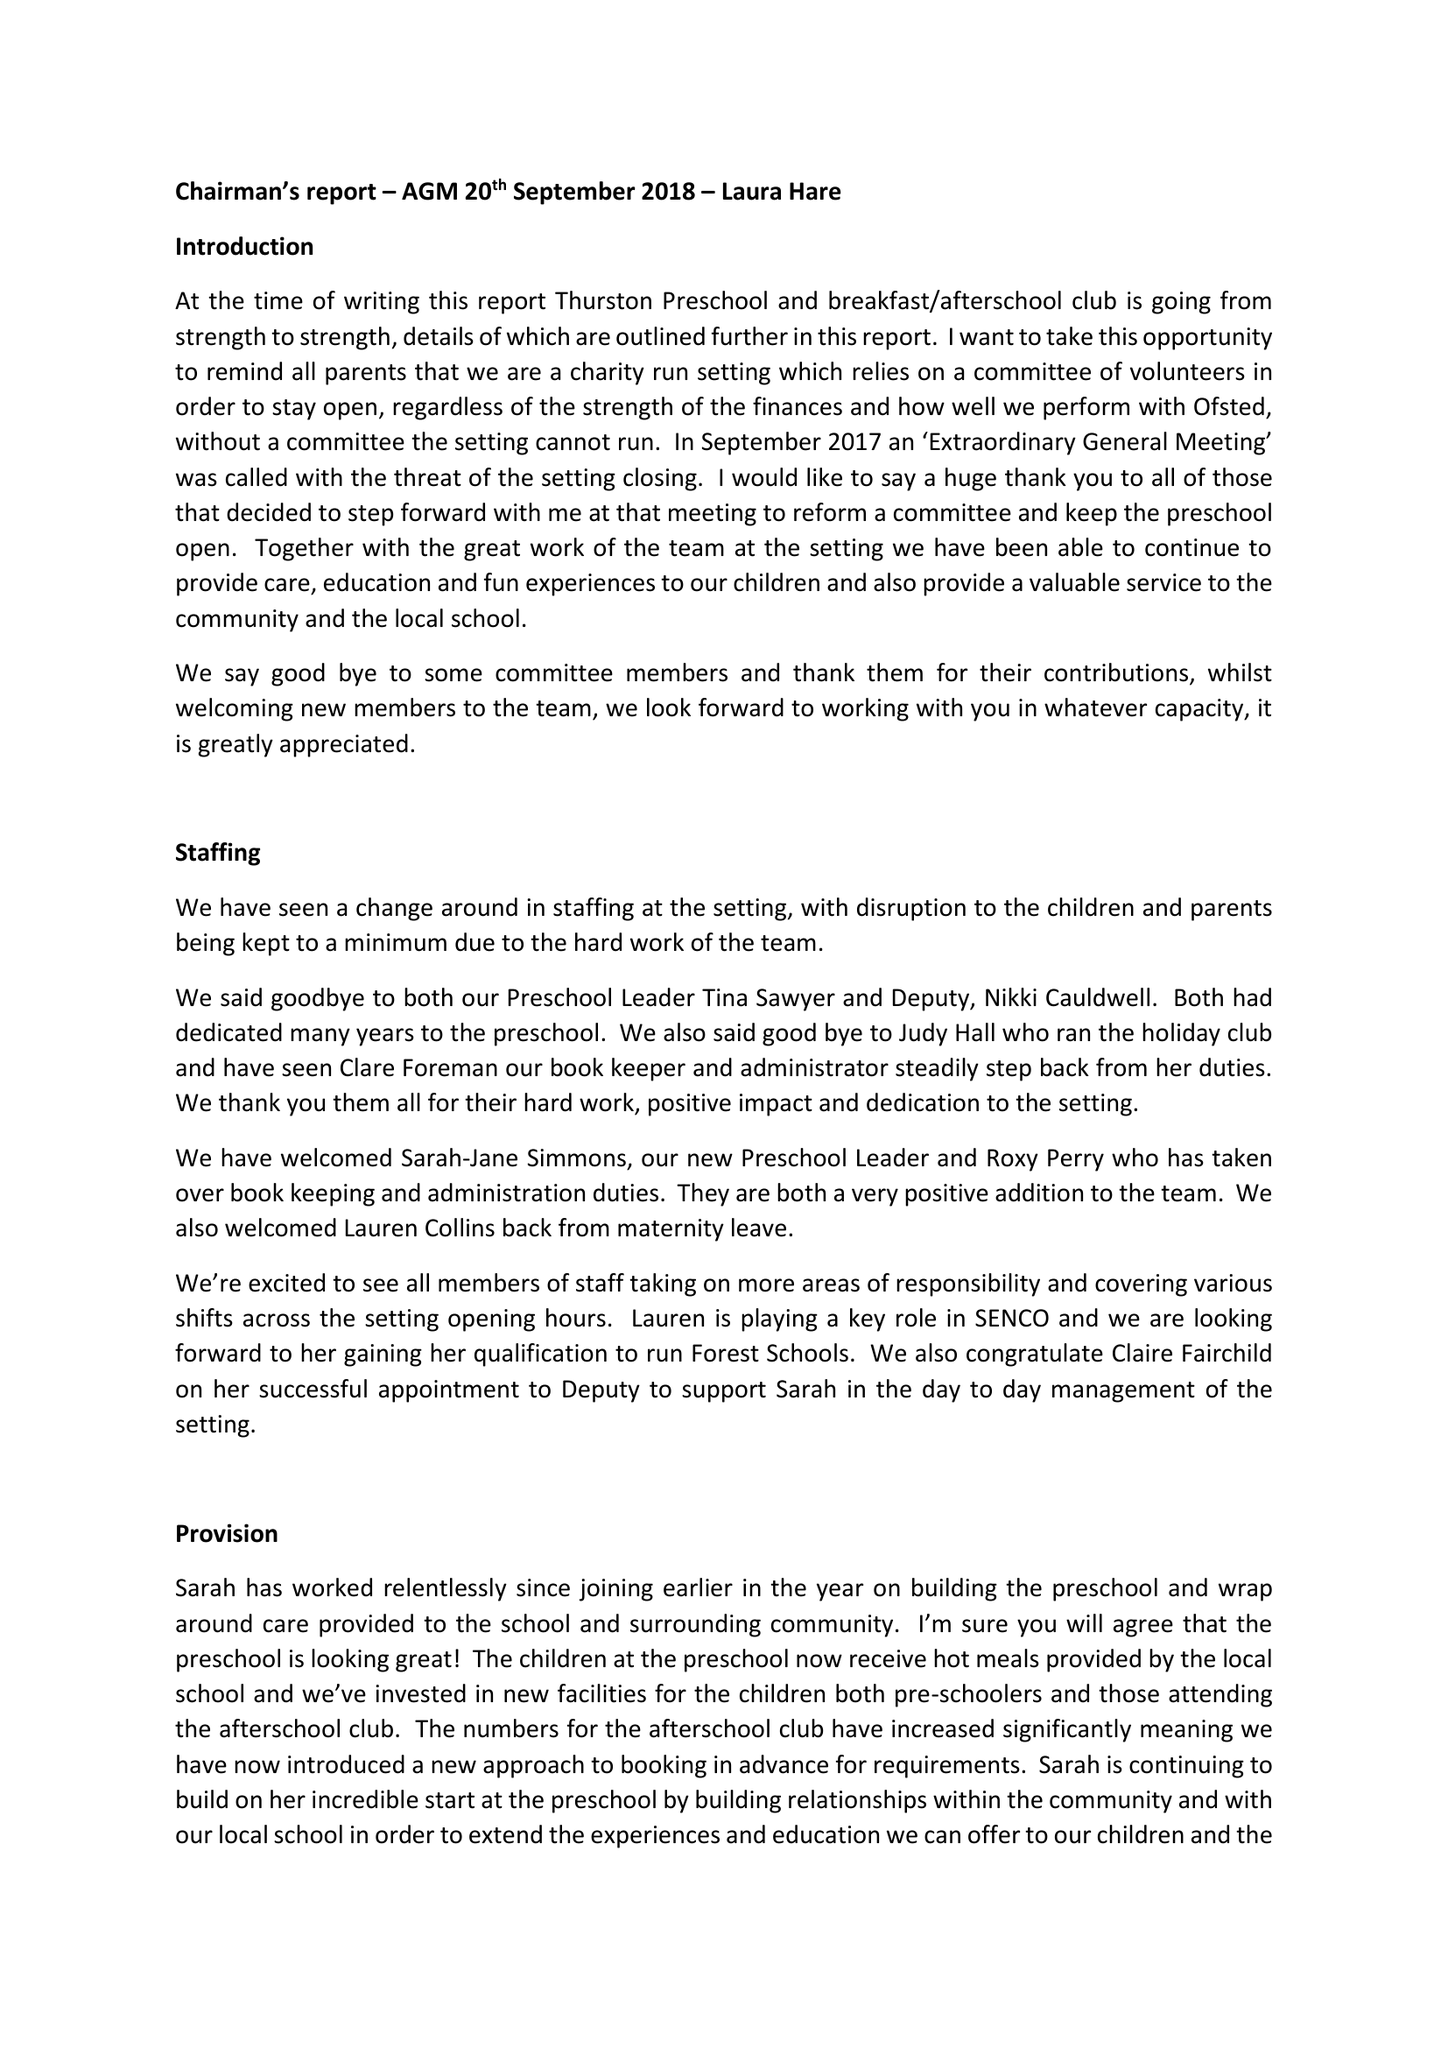What is the value for the spending_annually_in_british_pounds?
Answer the question using a single word or phrase. 95474.00 